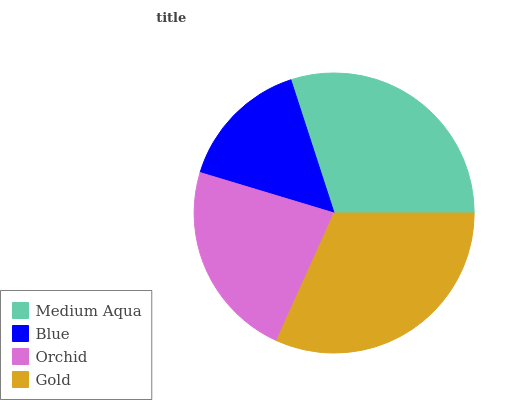Is Blue the minimum?
Answer yes or no. Yes. Is Gold the maximum?
Answer yes or no. Yes. Is Orchid the minimum?
Answer yes or no. No. Is Orchid the maximum?
Answer yes or no. No. Is Orchid greater than Blue?
Answer yes or no. Yes. Is Blue less than Orchid?
Answer yes or no. Yes. Is Blue greater than Orchid?
Answer yes or no. No. Is Orchid less than Blue?
Answer yes or no. No. Is Medium Aqua the high median?
Answer yes or no. Yes. Is Orchid the low median?
Answer yes or no. Yes. Is Orchid the high median?
Answer yes or no. No. Is Gold the low median?
Answer yes or no. No. 